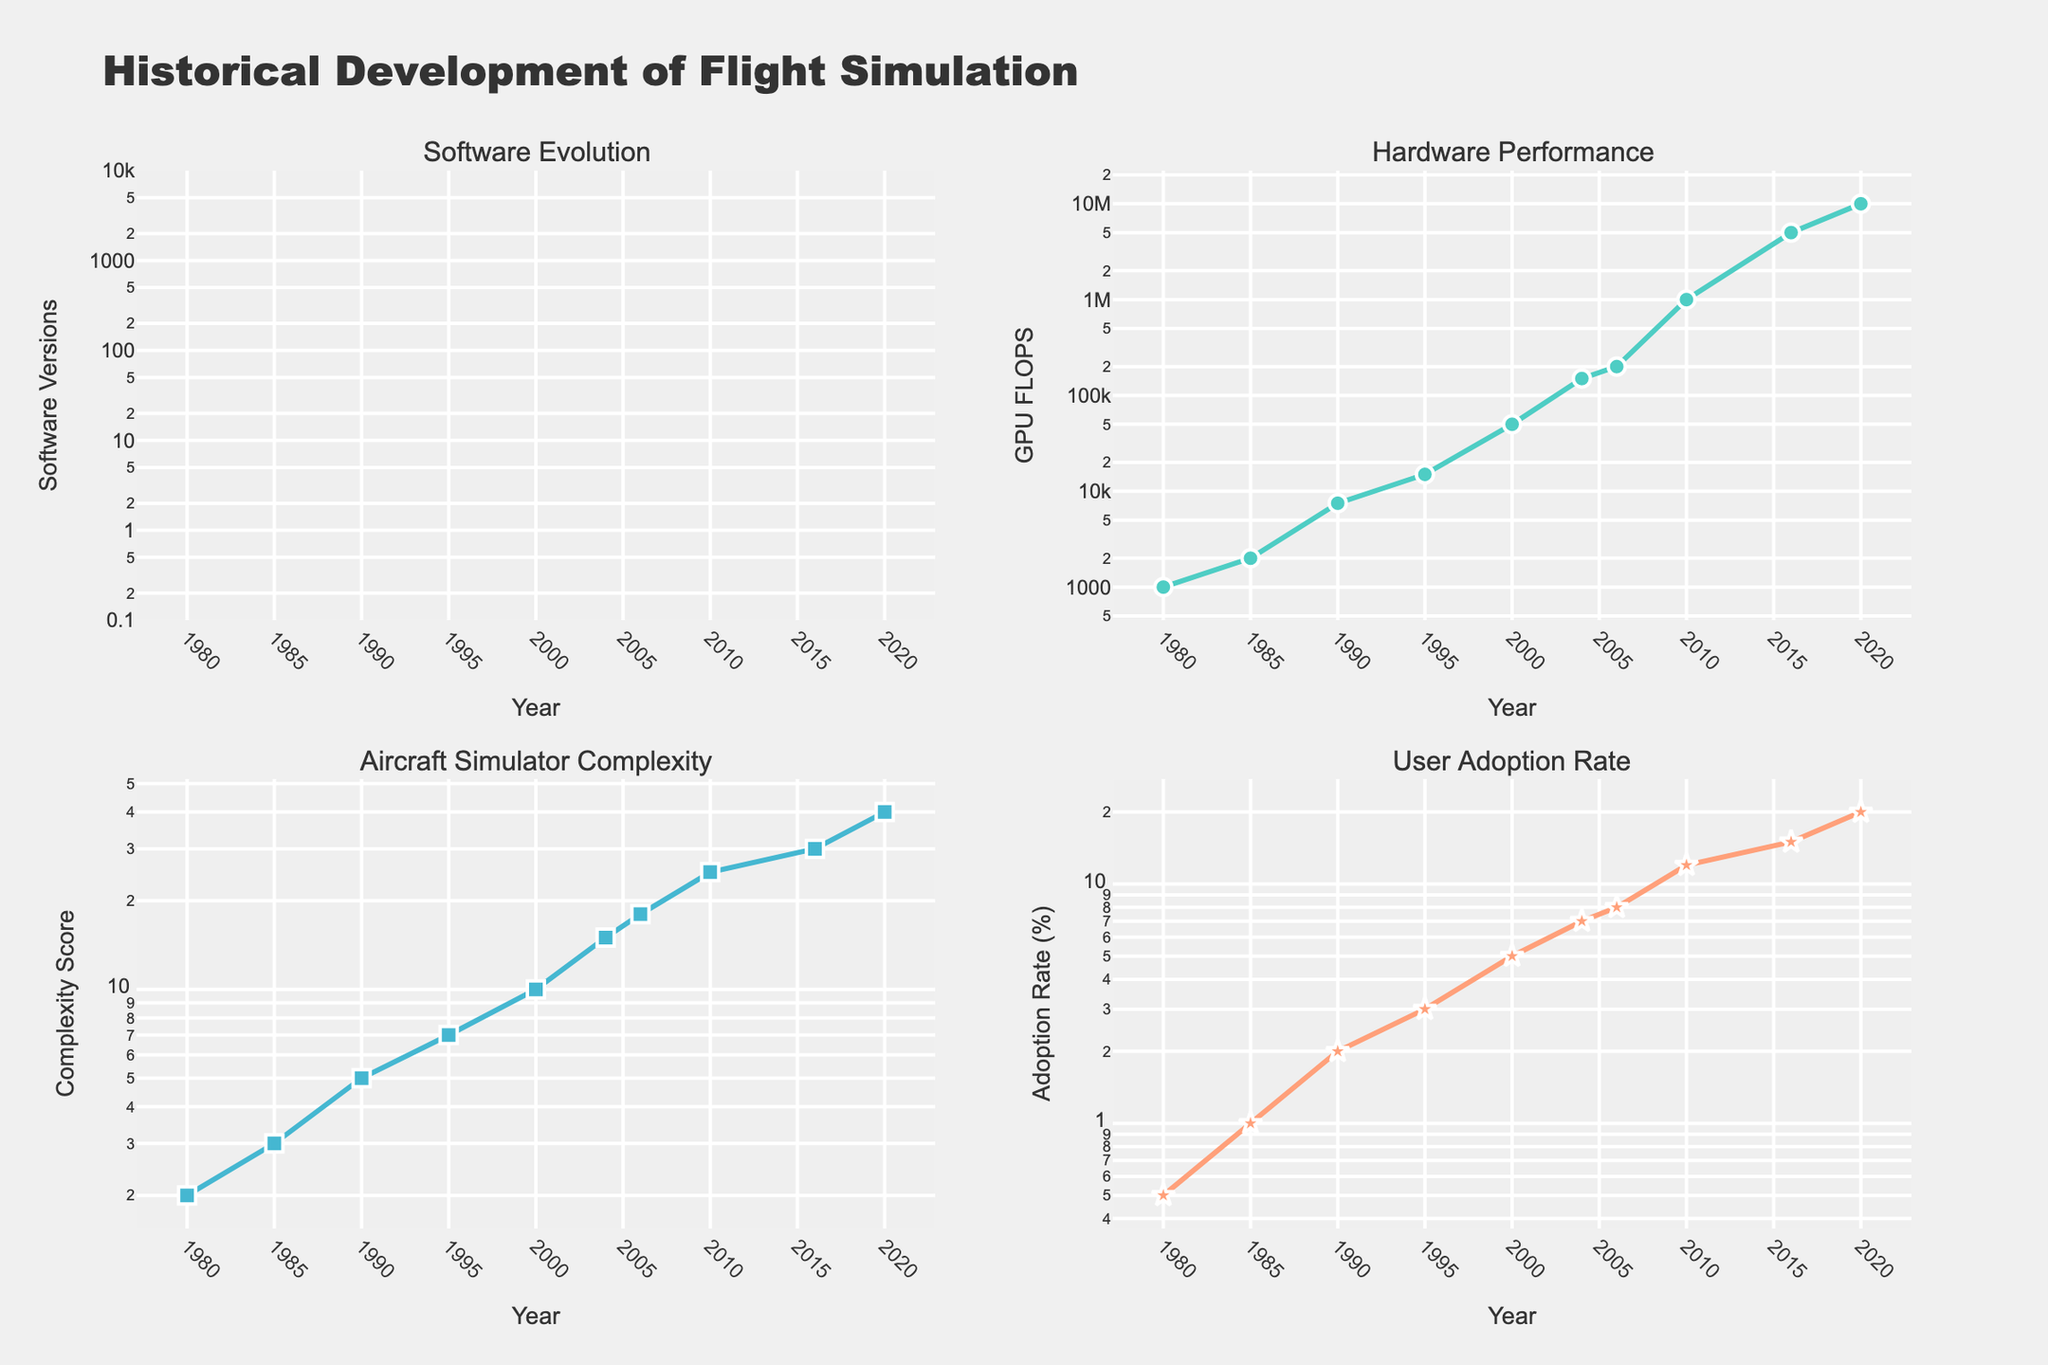What is the range of years covered in the figure? The x-axis of all subplots shows the years from the earliest to the latest listed, which can be identified by examining the start and end points of each plot. The data ranges from 1980 to 2020.
Answer: 1980 to 2020 Which flight simulation software was introduced in 2010? To find the specific software introduced in a given year, refer to the "Software Evolution" subplot. The point marked in 2010 corresponds to "Microsoft Flight Simulator X."
Answer: Microsoft Flight Simulator X How does the GPU FLOPS performance change over time? Look at the "Hardware Performance" subplot, which shows GPU FLOPS on a logarithmic scale along the y-axis. There is a marked increase in GPU FLOPS over the years from 1000 in 1980 to 10,000,000 in 2020.
Answer: Increases significantly What can you infer about the relationship between simulator complexity and user adoption rate over the years? Examine both the "Aircraft Simulator Complexity" and "User Adoption Rate" subplots. Both metrics increase over time. Complexity starts from 2 in 1980 to 40 in 2020, and user adoption rate from 0.5% to 20%. This implies there's a positive correlation between complexity and adoption over time.
Answer: Positive correlation What year saw the biggest jump in GPU FLOPS performance? By observing the "Hardware Performance" subplot, identify the interval with the steepest rise. The greatest increase happens between 2006 and 2010, from 200,000 to 1,000,000 GPU FLOPS.
Answer: Between 2006 and 2010 What is the trend of user adoption rate from 1980 to 2020? The "User Adoption Rate" subplot indicates this trend with points connected by lines. The user adoption rate shows an increasing trend over the years, rising from 0.5% in 1980 to 20% in 2020.
Answer: Increasing trend How does X-Plane 10 compare in complexity to Microsoft Flight Simulator 2020? Locate the points corresponding to X-Plane 10 (2016) and Microsoft Flight Simulator 2020 (2020) on the "Aircraft Simulator Complexity" subplot. X-Plane 10 has a complexity of 30, while Microsoft Flight Simulator 2020 has a complexity of 40.
Answer: Microsoft Flight Simulator 2020 is more complex Between which years does the complexity of the aircraft simulator increase from 5 to 10? Focus on the "Aircraft Simulator Complexity" subplot, and find the years where the values are 5 and 10, respectively. Complexity rises from 5 in 1990 to 10 in 2000, marking this interval.
Answer: 1990 to 2000 